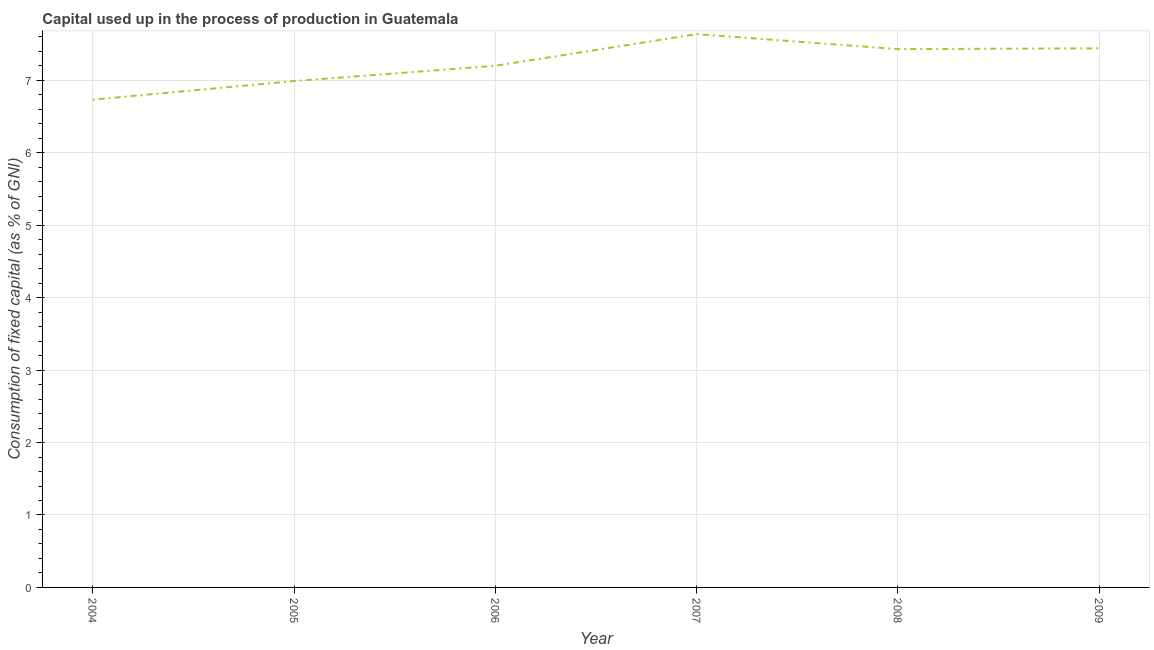What is the consumption of fixed capital in 2006?
Your answer should be very brief. 7.2. Across all years, what is the maximum consumption of fixed capital?
Offer a terse response. 7.64. Across all years, what is the minimum consumption of fixed capital?
Make the answer very short. 6.73. In which year was the consumption of fixed capital maximum?
Your answer should be compact. 2007. What is the sum of the consumption of fixed capital?
Offer a terse response. 43.44. What is the difference between the consumption of fixed capital in 2007 and 2009?
Provide a short and direct response. 0.2. What is the average consumption of fixed capital per year?
Your response must be concise. 7.24. What is the median consumption of fixed capital?
Give a very brief answer. 7.32. In how many years, is the consumption of fixed capital greater than 1 %?
Offer a terse response. 6. What is the ratio of the consumption of fixed capital in 2005 to that in 2008?
Ensure brevity in your answer.  0.94. Is the consumption of fixed capital in 2004 less than that in 2006?
Your answer should be compact. Yes. Is the difference between the consumption of fixed capital in 2004 and 2007 greater than the difference between any two years?
Provide a succinct answer. Yes. What is the difference between the highest and the second highest consumption of fixed capital?
Offer a terse response. 0.2. What is the difference between the highest and the lowest consumption of fixed capital?
Provide a succinct answer. 0.91. Does the consumption of fixed capital monotonically increase over the years?
Offer a very short reply. No. How many lines are there?
Your answer should be compact. 1. How many years are there in the graph?
Provide a succinct answer. 6. What is the difference between two consecutive major ticks on the Y-axis?
Give a very brief answer. 1. Are the values on the major ticks of Y-axis written in scientific E-notation?
Your response must be concise. No. What is the title of the graph?
Offer a very short reply. Capital used up in the process of production in Guatemala. What is the label or title of the X-axis?
Provide a short and direct response. Year. What is the label or title of the Y-axis?
Offer a very short reply. Consumption of fixed capital (as % of GNI). What is the Consumption of fixed capital (as % of GNI) in 2004?
Make the answer very short. 6.73. What is the Consumption of fixed capital (as % of GNI) of 2005?
Give a very brief answer. 6.99. What is the Consumption of fixed capital (as % of GNI) in 2006?
Your answer should be compact. 7.2. What is the Consumption of fixed capital (as % of GNI) of 2007?
Your response must be concise. 7.64. What is the Consumption of fixed capital (as % of GNI) of 2008?
Provide a succinct answer. 7.43. What is the Consumption of fixed capital (as % of GNI) of 2009?
Keep it short and to the point. 7.44. What is the difference between the Consumption of fixed capital (as % of GNI) in 2004 and 2005?
Provide a succinct answer. -0.26. What is the difference between the Consumption of fixed capital (as % of GNI) in 2004 and 2006?
Make the answer very short. -0.47. What is the difference between the Consumption of fixed capital (as % of GNI) in 2004 and 2007?
Give a very brief answer. -0.91. What is the difference between the Consumption of fixed capital (as % of GNI) in 2004 and 2008?
Make the answer very short. -0.7. What is the difference between the Consumption of fixed capital (as % of GNI) in 2004 and 2009?
Your answer should be very brief. -0.71. What is the difference between the Consumption of fixed capital (as % of GNI) in 2005 and 2006?
Your response must be concise. -0.21. What is the difference between the Consumption of fixed capital (as % of GNI) in 2005 and 2007?
Offer a terse response. -0.65. What is the difference between the Consumption of fixed capital (as % of GNI) in 2005 and 2008?
Offer a terse response. -0.44. What is the difference between the Consumption of fixed capital (as % of GNI) in 2005 and 2009?
Offer a very short reply. -0.45. What is the difference between the Consumption of fixed capital (as % of GNI) in 2006 and 2007?
Offer a terse response. -0.44. What is the difference between the Consumption of fixed capital (as % of GNI) in 2006 and 2008?
Your answer should be very brief. -0.23. What is the difference between the Consumption of fixed capital (as % of GNI) in 2006 and 2009?
Provide a short and direct response. -0.24. What is the difference between the Consumption of fixed capital (as % of GNI) in 2007 and 2008?
Your answer should be very brief. 0.21. What is the difference between the Consumption of fixed capital (as % of GNI) in 2007 and 2009?
Keep it short and to the point. 0.2. What is the difference between the Consumption of fixed capital (as % of GNI) in 2008 and 2009?
Offer a very short reply. -0.01. What is the ratio of the Consumption of fixed capital (as % of GNI) in 2004 to that in 2005?
Make the answer very short. 0.96. What is the ratio of the Consumption of fixed capital (as % of GNI) in 2004 to that in 2006?
Offer a terse response. 0.94. What is the ratio of the Consumption of fixed capital (as % of GNI) in 2004 to that in 2007?
Offer a very short reply. 0.88. What is the ratio of the Consumption of fixed capital (as % of GNI) in 2004 to that in 2008?
Your answer should be compact. 0.91. What is the ratio of the Consumption of fixed capital (as % of GNI) in 2004 to that in 2009?
Your response must be concise. 0.91. What is the ratio of the Consumption of fixed capital (as % of GNI) in 2005 to that in 2007?
Offer a terse response. 0.92. What is the ratio of the Consumption of fixed capital (as % of GNI) in 2005 to that in 2008?
Ensure brevity in your answer.  0.94. What is the ratio of the Consumption of fixed capital (as % of GNI) in 2005 to that in 2009?
Provide a succinct answer. 0.94. What is the ratio of the Consumption of fixed capital (as % of GNI) in 2006 to that in 2007?
Your answer should be very brief. 0.94. What is the ratio of the Consumption of fixed capital (as % of GNI) in 2006 to that in 2008?
Provide a succinct answer. 0.97. What is the ratio of the Consumption of fixed capital (as % of GNI) in 2007 to that in 2008?
Offer a terse response. 1.03. What is the ratio of the Consumption of fixed capital (as % of GNI) in 2008 to that in 2009?
Make the answer very short. 1. 